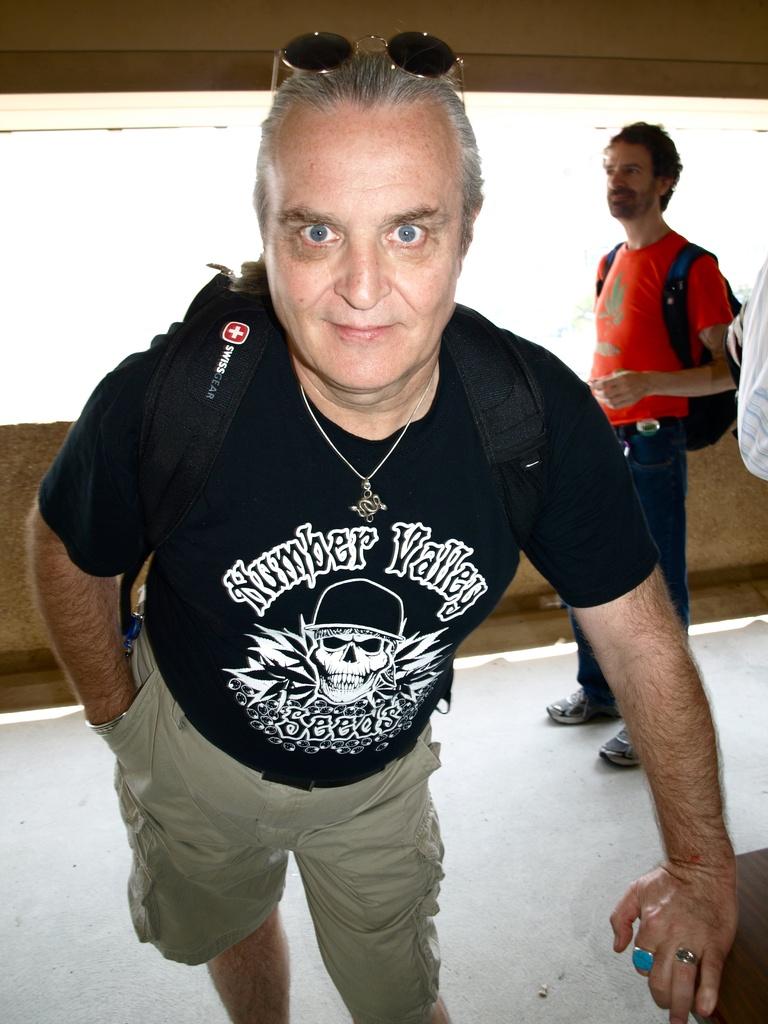What's the name of the valley on the shirt?
Ensure brevity in your answer.  Humber valley. What is the brand of the backpack?
Offer a terse response. Swiss gear. 